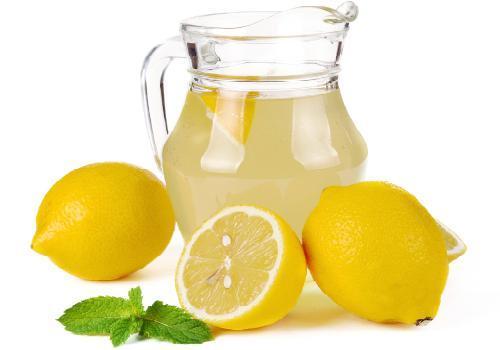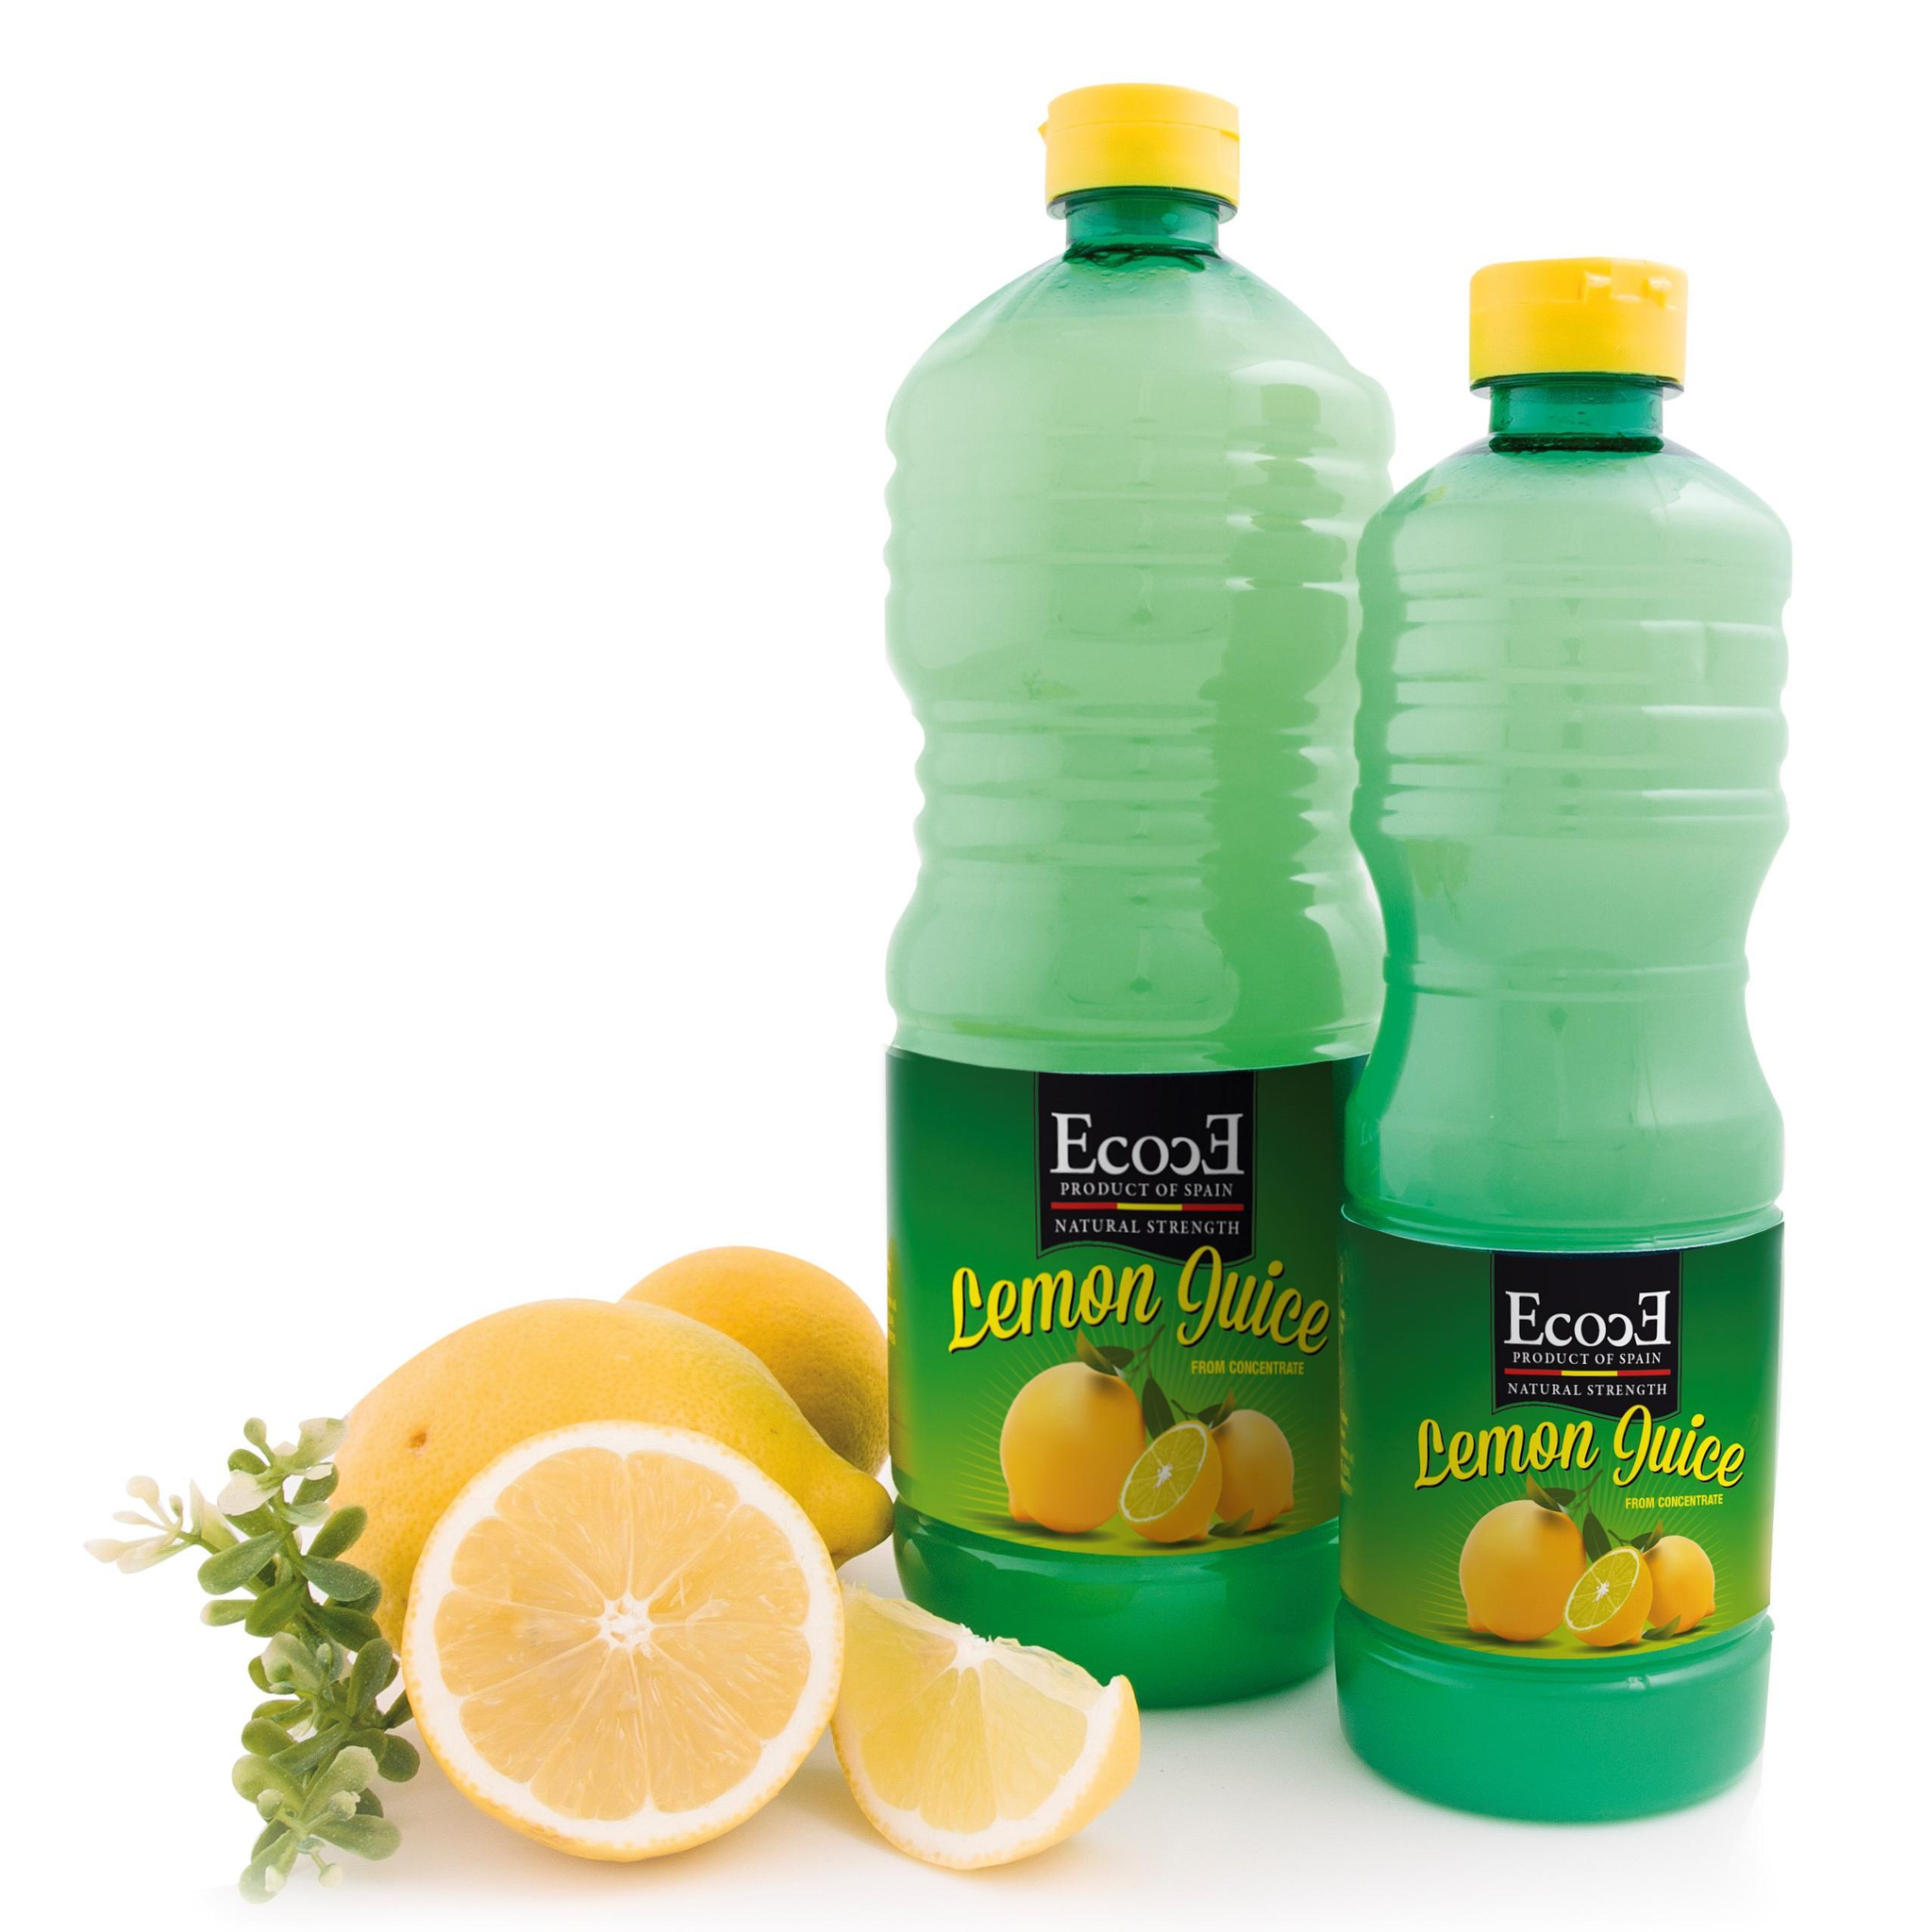The first image is the image on the left, the second image is the image on the right. Considering the images on both sides, is "There is a glass of lemonade with lemons next to it, there is 1/2 of a lemon and the lemon greens from the fruit are visible, the glass is smaller around on the bottom and tapers wider at the top" valid? Answer yes or no. No. 